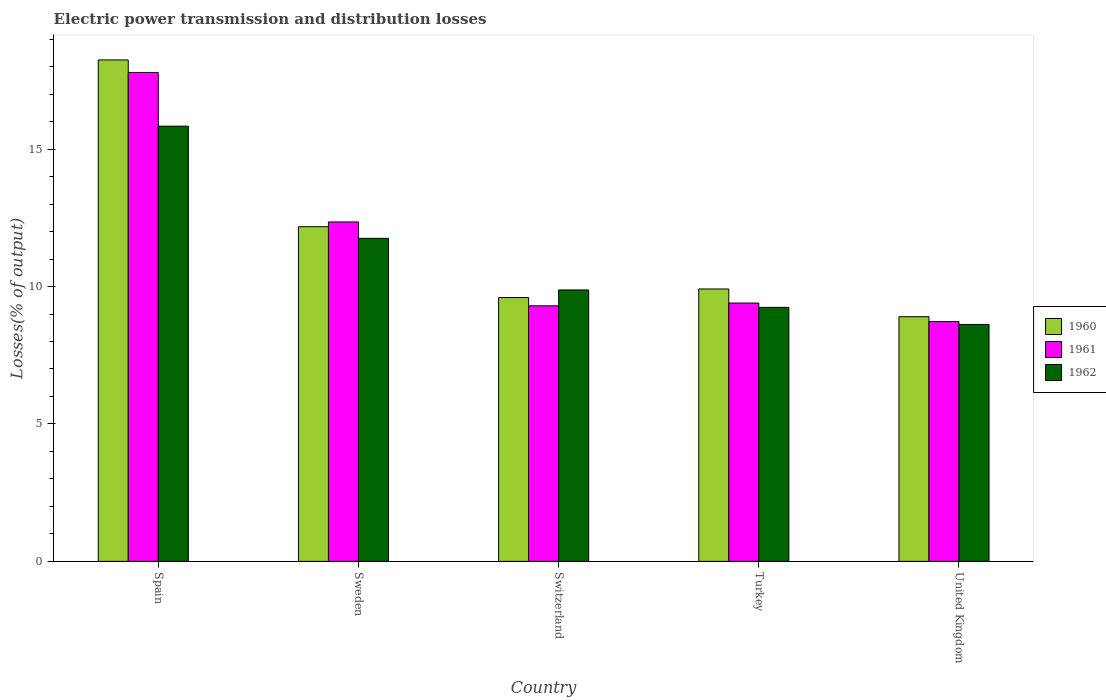Are the number of bars per tick equal to the number of legend labels?
Keep it short and to the point. Yes. What is the electric power transmission and distribution losses in 1961 in Switzerland?
Ensure brevity in your answer.  9.3. Across all countries, what is the maximum electric power transmission and distribution losses in 1962?
Offer a very short reply. 15.83. Across all countries, what is the minimum electric power transmission and distribution losses in 1961?
Offer a very short reply. 8.72. In which country was the electric power transmission and distribution losses in 1960 maximum?
Give a very brief answer. Spain. What is the total electric power transmission and distribution losses in 1960 in the graph?
Your answer should be very brief. 58.83. What is the difference between the electric power transmission and distribution losses in 1960 in Spain and that in Sweden?
Provide a succinct answer. 6.07. What is the difference between the electric power transmission and distribution losses in 1960 in Sweden and the electric power transmission and distribution losses in 1962 in Spain?
Provide a succinct answer. -3.66. What is the average electric power transmission and distribution losses in 1961 per country?
Provide a short and direct response. 11.51. What is the difference between the electric power transmission and distribution losses of/in 1962 and electric power transmission and distribution losses of/in 1961 in Sweden?
Offer a very short reply. -0.6. In how many countries, is the electric power transmission and distribution losses in 1960 greater than 14 %?
Provide a succinct answer. 1. What is the ratio of the electric power transmission and distribution losses in 1962 in Spain to that in Turkey?
Make the answer very short. 1.71. Is the difference between the electric power transmission and distribution losses in 1962 in Sweden and Turkey greater than the difference between the electric power transmission and distribution losses in 1961 in Sweden and Turkey?
Provide a succinct answer. No. What is the difference between the highest and the second highest electric power transmission and distribution losses in 1960?
Keep it short and to the point. -8.33. What is the difference between the highest and the lowest electric power transmission and distribution losses in 1962?
Make the answer very short. 7.21. What does the 2nd bar from the left in Spain represents?
Ensure brevity in your answer.  1961. Is it the case that in every country, the sum of the electric power transmission and distribution losses in 1962 and electric power transmission and distribution losses in 1960 is greater than the electric power transmission and distribution losses in 1961?
Offer a very short reply. Yes. How many countries are there in the graph?
Provide a succinct answer. 5. What is the difference between two consecutive major ticks on the Y-axis?
Ensure brevity in your answer.  5. Does the graph contain any zero values?
Offer a very short reply. No. Does the graph contain grids?
Make the answer very short. No. Where does the legend appear in the graph?
Offer a very short reply. Center right. How are the legend labels stacked?
Your response must be concise. Vertical. What is the title of the graph?
Make the answer very short. Electric power transmission and distribution losses. What is the label or title of the X-axis?
Give a very brief answer. Country. What is the label or title of the Y-axis?
Keep it short and to the point. Losses(% of output). What is the Losses(% of output) of 1960 in Spain?
Your answer should be compact. 18.24. What is the Losses(% of output) in 1961 in Spain?
Offer a terse response. 17.79. What is the Losses(% of output) in 1962 in Spain?
Ensure brevity in your answer.  15.83. What is the Losses(% of output) in 1960 in Sweden?
Give a very brief answer. 12.18. What is the Losses(% of output) in 1961 in Sweden?
Provide a short and direct response. 12.35. What is the Losses(% of output) of 1962 in Sweden?
Your answer should be very brief. 11.75. What is the Losses(% of output) in 1960 in Switzerland?
Offer a terse response. 9.6. What is the Losses(% of output) of 1961 in Switzerland?
Keep it short and to the point. 9.3. What is the Losses(% of output) of 1962 in Switzerland?
Offer a terse response. 9.88. What is the Losses(% of output) of 1960 in Turkey?
Your answer should be very brief. 9.91. What is the Losses(% of output) in 1961 in Turkey?
Your answer should be very brief. 9.4. What is the Losses(% of output) in 1962 in Turkey?
Keep it short and to the point. 9.24. What is the Losses(% of output) in 1960 in United Kingdom?
Make the answer very short. 8.9. What is the Losses(% of output) of 1961 in United Kingdom?
Ensure brevity in your answer.  8.72. What is the Losses(% of output) in 1962 in United Kingdom?
Provide a succinct answer. 8.62. Across all countries, what is the maximum Losses(% of output) in 1960?
Your response must be concise. 18.24. Across all countries, what is the maximum Losses(% of output) of 1961?
Provide a short and direct response. 17.79. Across all countries, what is the maximum Losses(% of output) in 1962?
Make the answer very short. 15.83. Across all countries, what is the minimum Losses(% of output) of 1960?
Provide a short and direct response. 8.9. Across all countries, what is the minimum Losses(% of output) of 1961?
Offer a terse response. 8.72. Across all countries, what is the minimum Losses(% of output) in 1962?
Offer a very short reply. 8.62. What is the total Losses(% of output) of 1960 in the graph?
Your response must be concise. 58.83. What is the total Losses(% of output) in 1961 in the graph?
Offer a very short reply. 57.56. What is the total Losses(% of output) in 1962 in the graph?
Provide a short and direct response. 55.33. What is the difference between the Losses(% of output) in 1960 in Spain and that in Sweden?
Provide a succinct answer. 6.07. What is the difference between the Losses(% of output) of 1961 in Spain and that in Sweden?
Provide a succinct answer. 5.44. What is the difference between the Losses(% of output) in 1962 in Spain and that in Sweden?
Your response must be concise. 4.08. What is the difference between the Losses(% of output) in 1960 in Spain and that in Switzerland?
Make the answer very short. 8.65. What is the difference between the Losses(% of output) in 1961 in Spain and that in Switzerland?
Make the answer very short. 8.49. What is the difference between the Losses(% of output) in 1962 in Spain and that in Switzerland?
Give a very brief answer. 5.96. What is the difference between the Losses(% of output) of 1960 in Spain and that in Turkey?
Keep it short and to the point. 8.33. What is the difference between the Losses(% of output) in 1961 in Spain and that in Turkey?
Ensure brevity in your answer.  8.39. What is the difference between the Losses(% of output) of 1962 in Spain and that in Turkey?
Keep it short and to the point. 6.59. What is the difference between the Losses(% of output) in 1960 in Spain and that in United Kingdom?
Give a very brief answer. 9.34. What is the difference between the Losses(% of output) in 1961 in Spain and that in United Kingdom?
Your response must be concise. 9.07. What is the difference between the Losses(% of output) of 1962 in Spain and that in United Kingdom?
Offer a terse response. 7.21. What is the difference between the Losses(% of output) in 1960 in Sweden and that in Switzerland?
Make the answer very short. 2.58. What is the difference between the Losses(% of output) in 1961 in Sweden and that in Switzerland?
Your response must be concise. 3.05. What is the difference between the Losses(% of output) of 1962 in Sweden and that in Switzerland?
Your answer should be very brief. 1.88. What is the difference between the Losses(% of output) of 1960 in Sweden and that in Turkey?
Make the answer very short. 2.27. What is the difference between the Losses(% of output) in 1961 in Sweden and that in Turkey?
Offer a terse response. 2.95. What is the difference between the Losses(% of output) in 1962 in Sweden and that in Turkey?
Make the answer very short. 2.51. What is the difference between the Losses(% of output) of 1960 in Sweden and that in United Kingdom?
Make the answer very short. 3.27. What is the difference between the Losses(% of output) of 1961 in Sweden and that in United Kingdom?
Offer a terse response. 3.63. What is the difference between the Losses(% of output) in 1962 in Sweden and that in United Kingdom?
Keep it short and to the point. 3.13. What is the difference between the Losses(% of output) in 1960 in Switzerland and that in Turkey?
Give a very brief answer. -0.31. What is the difference between the Losses(% of output) of 1961 in Switzerland and that in Turkey?
Ensure brevity in your answer.  -0.1. What is the difference between the Losses(% of output) of 1962 in Switzerland and that in Turkey?
Offer a terse response. 0.63. What is the difference between the Losses(% of output) of 1960 in Switzerland and that in United Kingdom?
Keep it short and to the point. 0.7. What is the difference between the Losses(% of output) of 1961 in Switzerland and that in United Kingdom?
Provide a succinct answer. 0.57. What is the difference between the Losses(% of output) of 1962 in Switzerland and that in United Kingdom?
Keep it short and to the point. 1.26. What is the difference between the Losses(% of output) of 1960 in Turkey and that in United Kingdom?
Keep it short and to the point. 1.01. What is the difference between the Losses(% of output) in 1961 in Turkey and that in United Kingdom?
Offer a very short reply. 0.68. What is the difference between the Losses(% of output) of 1962 in Turkey and that in United Kingdom?
Provide a short and direct response. 0.62. What is the difference between the Losses(% of output) of 1960 in Spain and the Losses(% of output) of 1961 in Sweden?
Your answer should be very brief. 5.89. What is the difference between the Losses(% of output) in 1960 in Spain and the Losses(% of output) in 1962 in Sweden?
Offer a terse response. 6.49. What is the difference between the Losses(% of output) in 1961 in Spain and the Losses(% of output) in 1962 in Sweden?
Make the answer very short. 6.04. What is the difference between the Losses(% of output) in 1960 in Spain and the Losses(% of output) in 1961 in Switzerland?
Ensure brevity in your answer.  8.95. What is the difference between the Losses(% of output) in 1960 in Spain and the Losses(% of output) in 1962 in Switzerland?
Your answer should be very brief. 8.37. What is the difference between the Losses(% of output) of 1961 in Spain and the Losses(% of output) of 1962 in Switzerland?
Your answer should be very brief. 7.91. What is the difference between the Losses(% of output) of 1960 in Spain and the Losses(% of output) of 1961 in Turkey?
Offer a very short reply. 8.85. What is the difference between the Losses(% of output) in 1960 in Spain and the Losses(% of output) in 1962 in Turkey?
Offer a very short reply. 9. What is the difference between the Losses(% of output) of 1961 in Spain and the Losses(% of output) of 1962 in Turkey?
Keep it short and to the point. 8.55. What is the difference between the Losses(% of output) in 1960 in Spain and the Losses(% of output) in 1961 in United Kingdom?
Offer a very short reply. 9.52. What is the difference between the Losses(% of output) of 1960 in Spain and the Losses(% of output) of 1962 in United Kingdom?
Give a very brief answer. 9.62. What is the difference between the Losses(% of output) of 1961 in Spain and the Losses(% of output) of 1962 in United Kingdom?
Provide a succinct answer. 9.17. What is the difference between the Losses(% of output) in 1960 in Sweden and the Losses(% of output) in 1961 in Switzerland?
Provide a short and direct response. 2.88. What is the difference between the Losses(% of output) of 1960 in Sweden and the Losses(% of output) of 1962 in Switzerland?
Offer a very short reply. 2.3. What is the difference between the Losses(% of output) in 1961 in Sweden and the Losses(% of output) in 1962 in Switzerland?
Your answer should be very brief. 2.47. What is the difference between the Losses(% of output) of 1960 in Sweden and the Losses(% of output) of 1961 in Turkey?
Your response must be concise. 2.78. What is the difference between the Losses(% of output) of 1960 in Sweden and the Losses(% of output) of 1962 in Turkey?
Keep it short and to the point. 2.94. What is the difference between the Losses(% of output) in 1961 in Sweden and the Losses(% of output) in 1962 in Turkey?
Your answer should be very brief. 3.11. What is the difference between the Losses(% of output) in 1960 in Sweden and the Losses(% of output) in 1961 in United Kingdom?
Your answer should be compact. 3.45. What is the difference between the Losses(% of output) in 1960 in Sweden and the Losses(% of output) in 1962 in United Kingdom?
Provide a succinct answer. 3.56. What is the difference between the Losses(% of output) in 1961 in Sweden and the Losses(% of output) in 1962 in United Kingdom?
Provide a succinct answer. 3.73. What is the difference between the Losses(% of output) of 1960 in Switzerland and the Losses(% of output) of 1961 in Turkey?
Provide a succinct answer. 0.2. What is the difference between the Losses(% of output) in 1960 in Switzerland and the Losses(% of output) in 1962 in Turkey?
Your answer should be compact. 0.36. What is the difference between the Losses(% of output) of 1961 in Switzerland and the Losses(% of output) of 1962 in Turkey?
Your answer should be very brief. 0.06. What is the difference between the Losses(% of output) of 1960 in Switzerland and the Losses(% of output) of 1961 in United Kingdom?
Keep it short and to the point. 0.88. What is the difference between the Losses(% of output) of 1960 in Switzerland and the Losses(% of output) of 1962 in United Kingdom?
Offer a very short reply. 0.98. What is the difference between the Losses(% of output) in 1961 in Switzerland and the Losses(% of output) in 1962 in United Kingdom?
Offer a very short reply. 0.68. What is the difference between the Losses(% of output) of 1960 in Turkey and the Losses(% of output) of 1961 in United Kingdom?
Give a very brief answer. 1.19. What is the difference between the Losses(% of output) in 1960 in Turkey and the Losses(% of output) in 1962 in United Kingdom?
Offer a terse response. 1.29. What is the difference between the Losses(% of output) of 1961 in Turkey and the Losses(% of output) of 1962 in United Kingdom?
Provide a short and direct response. 0.78. What is the average Losses(% of output) of 1960 per country?
Give a very brief answer. 11.77. What is the average Losses(% of output) of 1961 per country?
Provide a short and direct response. 11.51. What is the average Losses(% of output) of 1962 per country?
Provide a short and direct response. 11.07. What is the difference between the Losses(% of output) of 1960 and Losses(% of output) of 1961 in Spain?
Make the answer very short. 0.46. What is the difference between the Losses(% of output) of 1960 and Losses(% of output) of 1962 in Spain?
Offer a very short reply. 2.41. What is the difference between the Losses(% of output) of 1961 and Losses(% of output) of 1962 in Spain?
Your response must be concise. 1.95. What is the difference between the Losses(% of output) of 1960 and Losses(% of output) of 1961 in Sweden?
Ensure brevity in your answer.  -0.17. What is the difference between the Losses(% of output) of 1960 and Losses(% of output) of 1962 in Sweden?
Your answer should be compact. 0.42. What is the difference between the Losses(% of output) of 1961 and Losses(% of output) of 1962 in Sweden?
Offer a very short reply. 0.6. What is the difference between the Losses(% of output) of 1960 and Losses(% of output) of 1961 in Switzerland?
Provide a short and direct response. 0.3. What is the difference between the Losses(% of output) of 1960 and Losses(% of output) of 1962 in Switzerland?
Your answer should be compact. -0.28. What is the difference between the Losses(% of output) in 1961 and Losses(% of output) in 1962 in Switzerland?
Your response must be concise. -0.58. What is the difference between the Losses(% of output) in 1960 and Losses(% of output) in 1961 in Turkey?
Offer a very short reply. 0.51. What is the difference between the Losses(% of output) of 1960 and Losses(% of output) of 1962 in Turkey?
Provide a succinct answer. 0.67. What is the difference between the Losses(% of output) of 1961 and Losses(% of output) of 1962 in Turkey?
Keep it short and to the point. 0.16. What is the difference between the Losses(% of output) of 1960 and Losses(% of output) of 1961 in United Kingdom?
Make the answer very short. 0.18. What is the difference between the Losses(% of output) in 1960 and Losses(% of output) in 1962 in United Kingdom?
Ensure brevity in your answer.  0.28. What is the difference between the Losses(% of output) in 1961 and Losses(% of output) in 1962 in United Kingdom?
Provide a succinct answer. 0.1. What is the ratio of the Losses(% of output) in 1960 in Spain to that in Sweden?
Offer a very short reply. 1.5. What is the ratio of the Losses(% of output) of 1961 in Spain to that in Sweden?
Provide a short and direct response. 1.44. What is the ratio of the Losses(% of output) in 1962 in Spain to that in Sweden?
Ensure brevity in your answer.  1.35. What is the ratio of the Losses(% of output) of 1960 in Spain to that in Switzerland?
Your answer should be compact. 1.9. What is the ratio of the Losses(% of output) in 1961 in Spain to that in Switzerland?
Provide a succinct answer. 1.91. What is the ratio of the Losses(% of output) of 1962 in Spain to that in Switzerland?
Your answer should be compact. 1.6. What is the ratio of the Losses(% of output) of 1960 in Spain to that in Turkey?
Make the answer very short. 1.84. What is the ratio of the Losses(% of output) in 1961 in Spain to that in Turkey?
Your answer should be compact. 1.89. What is the ratio of the Losses(% of output) in 1962 in Spain to that in Turkey?
Give a very brief answer. 1.71. What is the ratio of the Losses(% of output) in 1960 in Spain to that in United Kingdom?
Keep it short and to the point. 2.05. What is the ratio of the Losses(% of output) in 1961 in Spain to that in United Kingdom?
Your response must be concise. 2.04. What is the ratio of the Losses(% of output) in 1962 in Spain to that in United Kingdom?
Provide a succinct answer. 1.84. What is the ratio of the Losses(% of output) of 1960 in Sweden to that in Switzerland?
Provide a succinct answer. 1.27. What is the ratio of the Losses(% of output) of 1961 in Sweden to that in Switzerland?
Your response must be concise. 1.33. What is the ratio of the Losses(% of output) in 1962 in Sweden to that in Switzerland?
Offer a terse response. 1.19. What is the ratio of the Losses(% of output) of 1960 in Sweden to that in Turkey?
Provide a succinct answer. 1.23. What is the ratio of the Losses(% of output) in 1961 in Sweden to that in Turkey?
Offer a terse response. 1.31. What is the ratio of the Losses(% of output) of 1962 in Sweden to that in Turkey?
Keep it short and to the point. 1.27. What is the ratio of the Losses(% of output) of 1960 in Sweden to that in United Kingdom?
Offer a terse response. 1.37. What is the ratio of the Losses(% of output) of 1961 in Sweden to that in United Kingdom?
Offer a terse response. 1.42. What is the ratio of the Losses(% of output) of 1962 in Sweden to that in United Kingdom?
Keep it short and to the point. 1.36. What is the ratio of the Losses(% of output) in 1960 in Switzerland to that in Turkey?
Your answer should be compact. 0.97. What is the ratio of the Losses(% of output) of 1961 in Switzerland to that in Turkey?
Your answer should be compact. 0.99. What is the ratio of the Losses(% of output) in 1962 in Switzerland to that in Turkey?
Ensure brevity in your answer.  1.07. What is the ratio of the Losses(% of output) of 1960 in Switzerland to that in United Kingdom?
Make the answer very short. 1.08. What is the ratio of the Losses(% of output) of 1961 in Switzerland to that in United Kingdom?
Your response must be concise. 1.07. What is the ratio of the Losses(% of output) in 1962 in Switzerland to that in United Kingdom?
Make the answer very short. 1.15. What is the ratio of the Losses(% of output) in 1960 in Turkey to that in United Kingdom?
Give a very brief answer. 1.11. What is the ratio of the Losses(% of output) in 1961 in Turkey to that in United Kingdom?
Your response must be concise. 1.08. What is the ratio of the Losses(% of output) of 1962 in Turkey to that in United Kingdom?
Your answer should be compact. 1.07. What is the difference between the highest and the second highest Losses(% of output) in 1960?
Keep it short and to the point. 6.07. What is the difference between the highest and the second highest Losses(% of output) of 1961?
Provide a succinct answer. 5.44. What is the difference between the highest and the second highest Losses(% of output) of 1962?
Ensure brevity in your answer.  4.08. What is the difference between the highest and the lowest Losses(% of output) in 1960?
Your answer should be compact. 9.34. What is the difference between the highest and the lowest Losses(% of output) in 1961?
Provide a succinct answer. 9.07. What is the difference between the highest and the lowest Losses(% of output) of 1962?
Give a very brief answer. 7.21. 